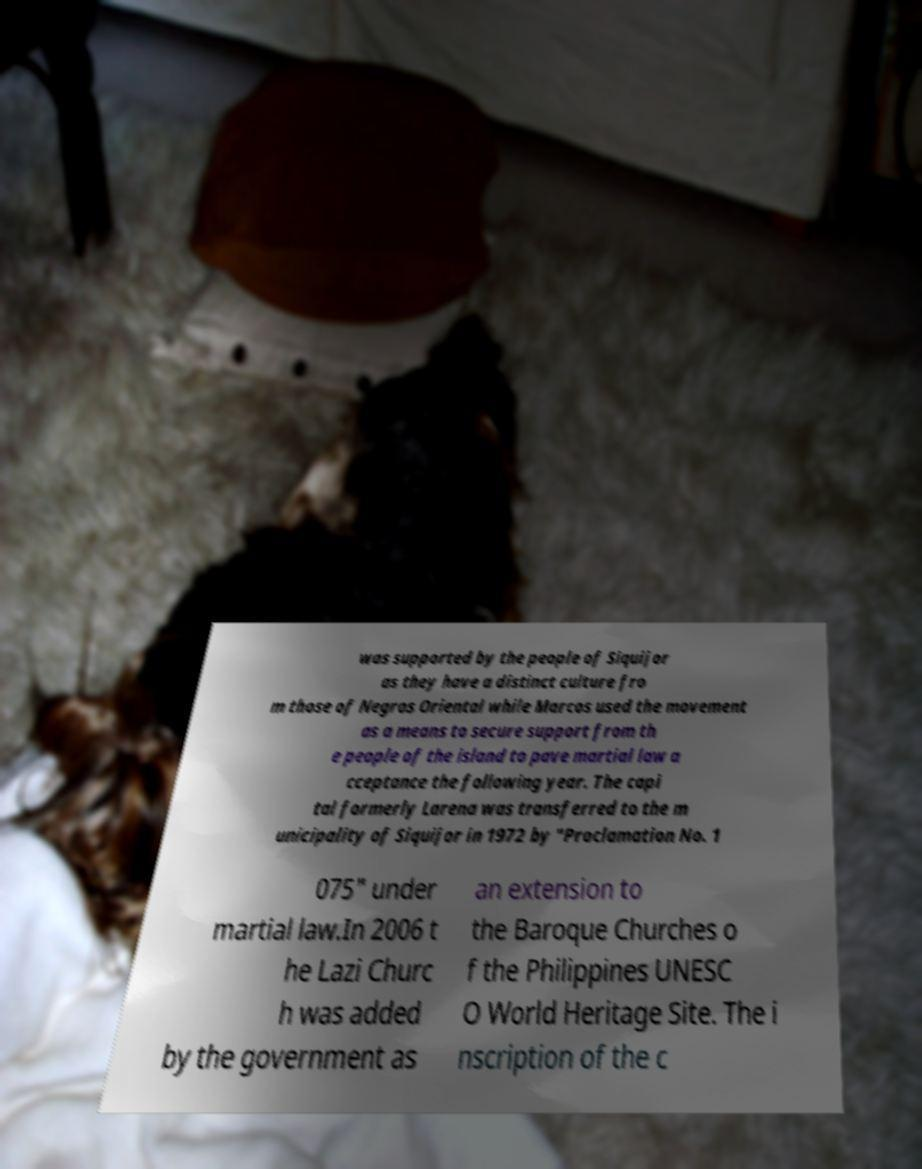Could you assist in decoding the text presented in this image and type it out clearly? was supported by the people of Siquijor as they have a distinct culture fro m those of Negros Oriental while Marcos used the movement as a means to secure support from th e people of the island to pave martial law a cceptance the following year. The capi tal formerly Larena was transferred to the m unicipality of Siquijor in 1972 by "Proclamation No. 1 075" under martial law.In 2006 t he Lazi Churc h was added by the government as an extension to the Baroque Churches o f the Philippines UNESC O World Heritage Site. The i nscription of the c 